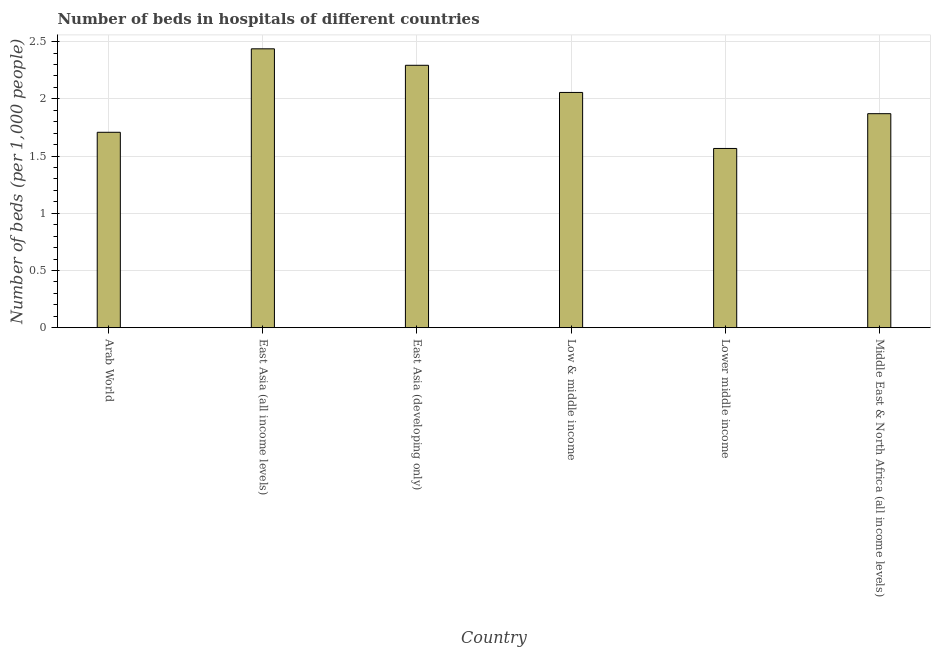Does the graph contain any zero values?
Offer a very short reply. No. Does the graph contain grids?
Offer a very short reply. Yes. What is the title of the graph?
Provide a succinct answer. Number of beds in hospitals of different countries. What is the label or title of the Y-axis?
Give a very brief answer. Number of beds (per 1,0 people). What is the number of hospital beds in Lower middle income?
Keep it short and to the point. 1.57. Across all countries, what is the maximum number of hospital beds?
Provide a succinct answer. 2.44. Across all countries, what is the minimum number of hospital beds?
Offer a terse response. 1.57. In which country was the number of hospital beds maximum?
Ensure brevity in your answer.  East Asia (all income levels). In which country was the number of hospital beds minimum?
Provide a succinct answer. Lower middle income. What is the sum of the number of hospital beds?
Offer a very short reply. 11.93. What is the difference between the number of hospital beds in East Asia (all income levels) and Middle East & North Africa (all income levels)?
Your answer should be very brief. 0.57. What is the average number of hospital beds per country?
Provide a succinct answer. 1.99. What is the median number of hospital beds?
Offer a very short reply. 1.96. In how many countries, is the number of hospital beds greater than 2.4 %?
Your answer should be very brief. 1. What is the ratio of the number of hospital beds in Arab World to that in Low & middle income?
Offer a terse response. 0.83. Is the number of hospital beds in Low & middle income less than that in Lower middle income?
Make the answer very short. No. Is the difference between the number of hospital beds in Low & middle income and Lower middle income greater than the difference between any two countries?
Your answer should be very brief. No. What is the difference between the highest and the second highest number of hospital beds?
Provide a succinct answer. 0.14. Is the sum of the number of hospital beds in East Asia (developing only) and Lower middle income greater than the maximum number of hospital beds across all countries?
Your response must be concise. Yes. What is the difference between the highest and the lowest number of hospital beds?
Provide a succinct answer. 0.87. How many bars are there?
Keep it short and to the point. 6. Are all the bars in the graph horizontal?
Keep it short and to the point. No. Are the values on the major ticks of Y-axis written in scientific E-notation?
Your answer should be very brief. No. What is the Number of beds (per 1,000 people) in Arab World?
Your response must be concise. 1.71. What is the Number of beds (per 1,000 people) of East Asia (all income levels)?
Keep it short and to the point. 2.44. What is the Number of beds (per 1,000 people) of East Asia (developing only)?
Ensure brevity in your answer.  2.29. What is the Number of beds (per 1,000 people) in Low & middle income?
Provide a short and direct response. 2.06. What is the Number of beds (per 1,000 people) in Lower middle income?
Offer a very short reply. 1.57. What is the Number of beds (per 1,000 people) in Middle East & North Africa (all income levels)?
Your response must be concise. 1.87. What is the difference between the Number of beds (per 1,000 people) in Arab World and East Asia (all income levels)?
Provide a succinct answer. -0.73. What is the difference between the Number of beds (per 1,000 people) in Arab World and East Asia (developing only)?
Offer a terse response. -0.59. What is the difference between the Number of beds (per 1,000 people) in Arab World and Low & middle income?
Offer a terse response. -0.35. What is the difference between the Number of beds (per 1,000 people) in Arab World and Lower middle income?
Provide a short and direct response. 0.14. What is the difference between the Number of beds (per 1,000 people) in Arab World and Middle East & North Africa (all income levels)?
Offer a very short reply. -0.16. What is the difference between the Number of beds (per 1,000 people) in East Asia (all income levels) and East Asia (developing only)?
Your answer should be compact. 0.14. What is the difference between the Number of beds (per 1,000 people) in East Asia (all income levels) and Low & middle income?
Offer a terse response. 0.38. What is the difference between the Number of beds (per 1,000 people) in East Asia (all income levels) and Lower middle income?
Give a very brief answer. 0.87. What is the difference between the Number of beds (per 1,000 people) in East Asia (all income levels) and Middle East & North Africa (all income levels)?
Keep it short and to the point. 0.57. What is the difference between the Number of beds (per 1,000 people) in East Asia (developing only) and Low & middle income?
Ensure brevity in your answer.  0.24. What is the difference between the Number of beds (per 1,000 people) in East Asia (developing only) and Lower middle income?
Make the answer very short. 0.73. What is the difference between the Number of beds (per 1,000 people) in East Asia (developing only) and Middle East & North Africa (all income levels)?
Ensure brevity in your answer.  0.42. What is the difference between the Number of beds (per 1,000 people) in Low & middle income and Lower middle income?
Ensure brevity in your answer.  0.49. What is the difference between the Number of beds (per 1,000 people) in Low & middle income and Middle East & North Africa (all income levels)?
Your answer should be very brief. 0.19. What is the difference between the Number of beds (per 1,000 people) in Lower middle income and Middle East & North Africa (all income levels)?
Provide a short and direct response. -0.3. What is the ratio of the Number of beds (per 1,000 people) in Arab World to that in East Asia (all income levels)?
Ensure brevity in your answer.  0.7. What is the ratio of the Number of beds (per 1,000 people) in Arab World to that in East Asia (developing only)?
Keep it short and to the point. 0.74. What is the ratio of the Number of beds (per 1,000 people) in Arab World to that in Low & middle income?
Give a very brief answer. 0.83. What is the ratio of the Number of beds (per 1,000 people) in Arab World to that in Lower middle income?
Your answer should be compact. 1.09. What is the ratio of the Number of beds (per 1,000 people) in East Asia (all income levels) to that in East Asia (developing only)?
Your answer should be compact. 1.06. What is the ratio of the Number of beds (per 1,000 people) in East Asia (all income levels) to that in Low & middle income?
Offer a terse response. 1.19. What is the ratio of the Number of beds (per 1,000 people) in East Asia (all income levels) to that in Lower middle income?
Offer a terse response. 1.56. What is the ratio of the Number of beds (per 1,000 people) in East Asia (all income levels) to that in Middle East & North Africa (all income levels)?
Provide a succinct answer. 1.3. What is the ratio of the Number of beds (per 1,000 people) in East Asia (developing only) to that in Low & middle income?
Provide a succinct answer. 1.11. What is the ratio of the Number of beds (per 1,000 people) in East Asia (developing only) to that in Lower middle income?
Provide a succinct answer. 1.46. What is the ratio of the Number of beds (per 1,000 people) in East Asia (developing only) to that in Middle East & North Africa (all income levels)?
Your answer should be very brief. 1.23. What is the ratio of the Number of beds (per 1,000 people) in Low & middle income to that in Lower middle income?
Offer a terse response. 1.31. What is the ratio of the Number of beds (per 1,000 people) in Low & middle income to that in Middle East & North Africa (all income levels)?
Provide a short and direct response. 1.1. What is the ratio of the Number of beds (per 1,000 people) in Lower middle income to that in Middle East & North Africa (all income levels)?
Make the answer very short. 0.84. 